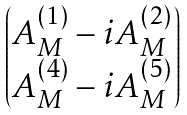<formula> <loc_0><loc_0><loc_500><loc_500>\begin{pmatrix} A _ { M } ^ { ( 1 ) } - i A _ { M } ^ { ( 2 ) } \\ A _ { M } ^ { ( 4 ) } - i A _ { M } ^ { ( 5 ) } \end{pmatrix}</formula> 